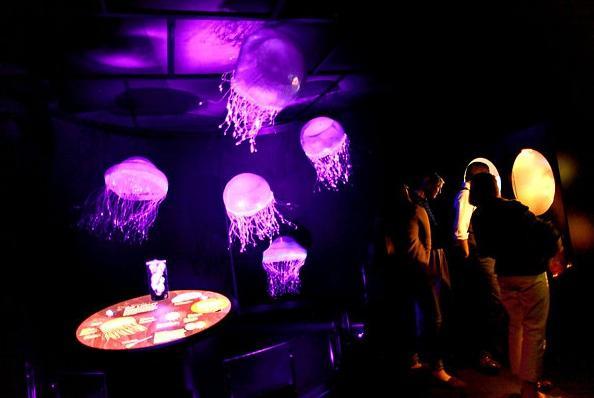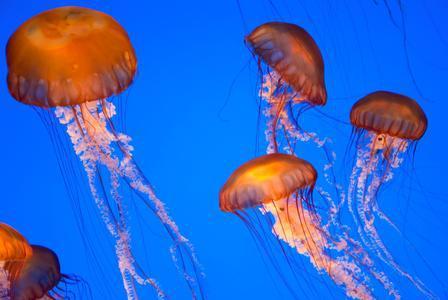The first image is the image on the left, the second image is the image on the right. Considering the images on both sides, is "The right image has fewer than four jellyfish." valid? Answer yes or no. No. The first image is the image on the left, the second image is the image on the right. Examine the images to the left and right. Is the description "Right and left images each show the same neutral-colored type of jellyfish." accurate? Answer yes or no. No. 